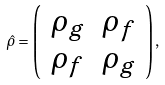Convert formula to latex. <formula><loc_0><loc_0><loc_500><loc_500>\hat { \rho } = \left ( \begin{array} { c c } \rho _ { g } & \rho _ { f } \\ \rho _ { f } & \rho _ { g } \end{array} \right ) ,</formula> 